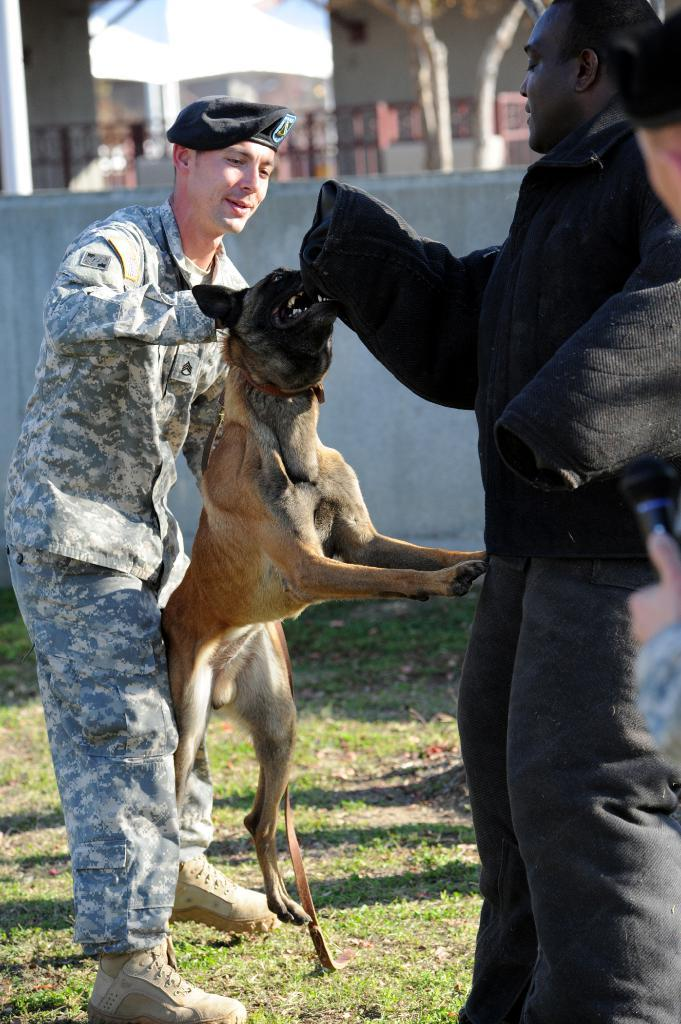How many people are in the image? There are three people in the image. What are the people on the right wearing? The people on the right are wearing black dresses. What is the person on the left holding? The person on the left is holding a dog. What can be seen in the background of the image? There are buildings visible in the background. Where is the throne located in the image? There is no throne present in the image. What type of ear is visible on the dog in the image? There is no ear visible on the dog in the image, as the dog is being held by the person on the left and not shown in full. 